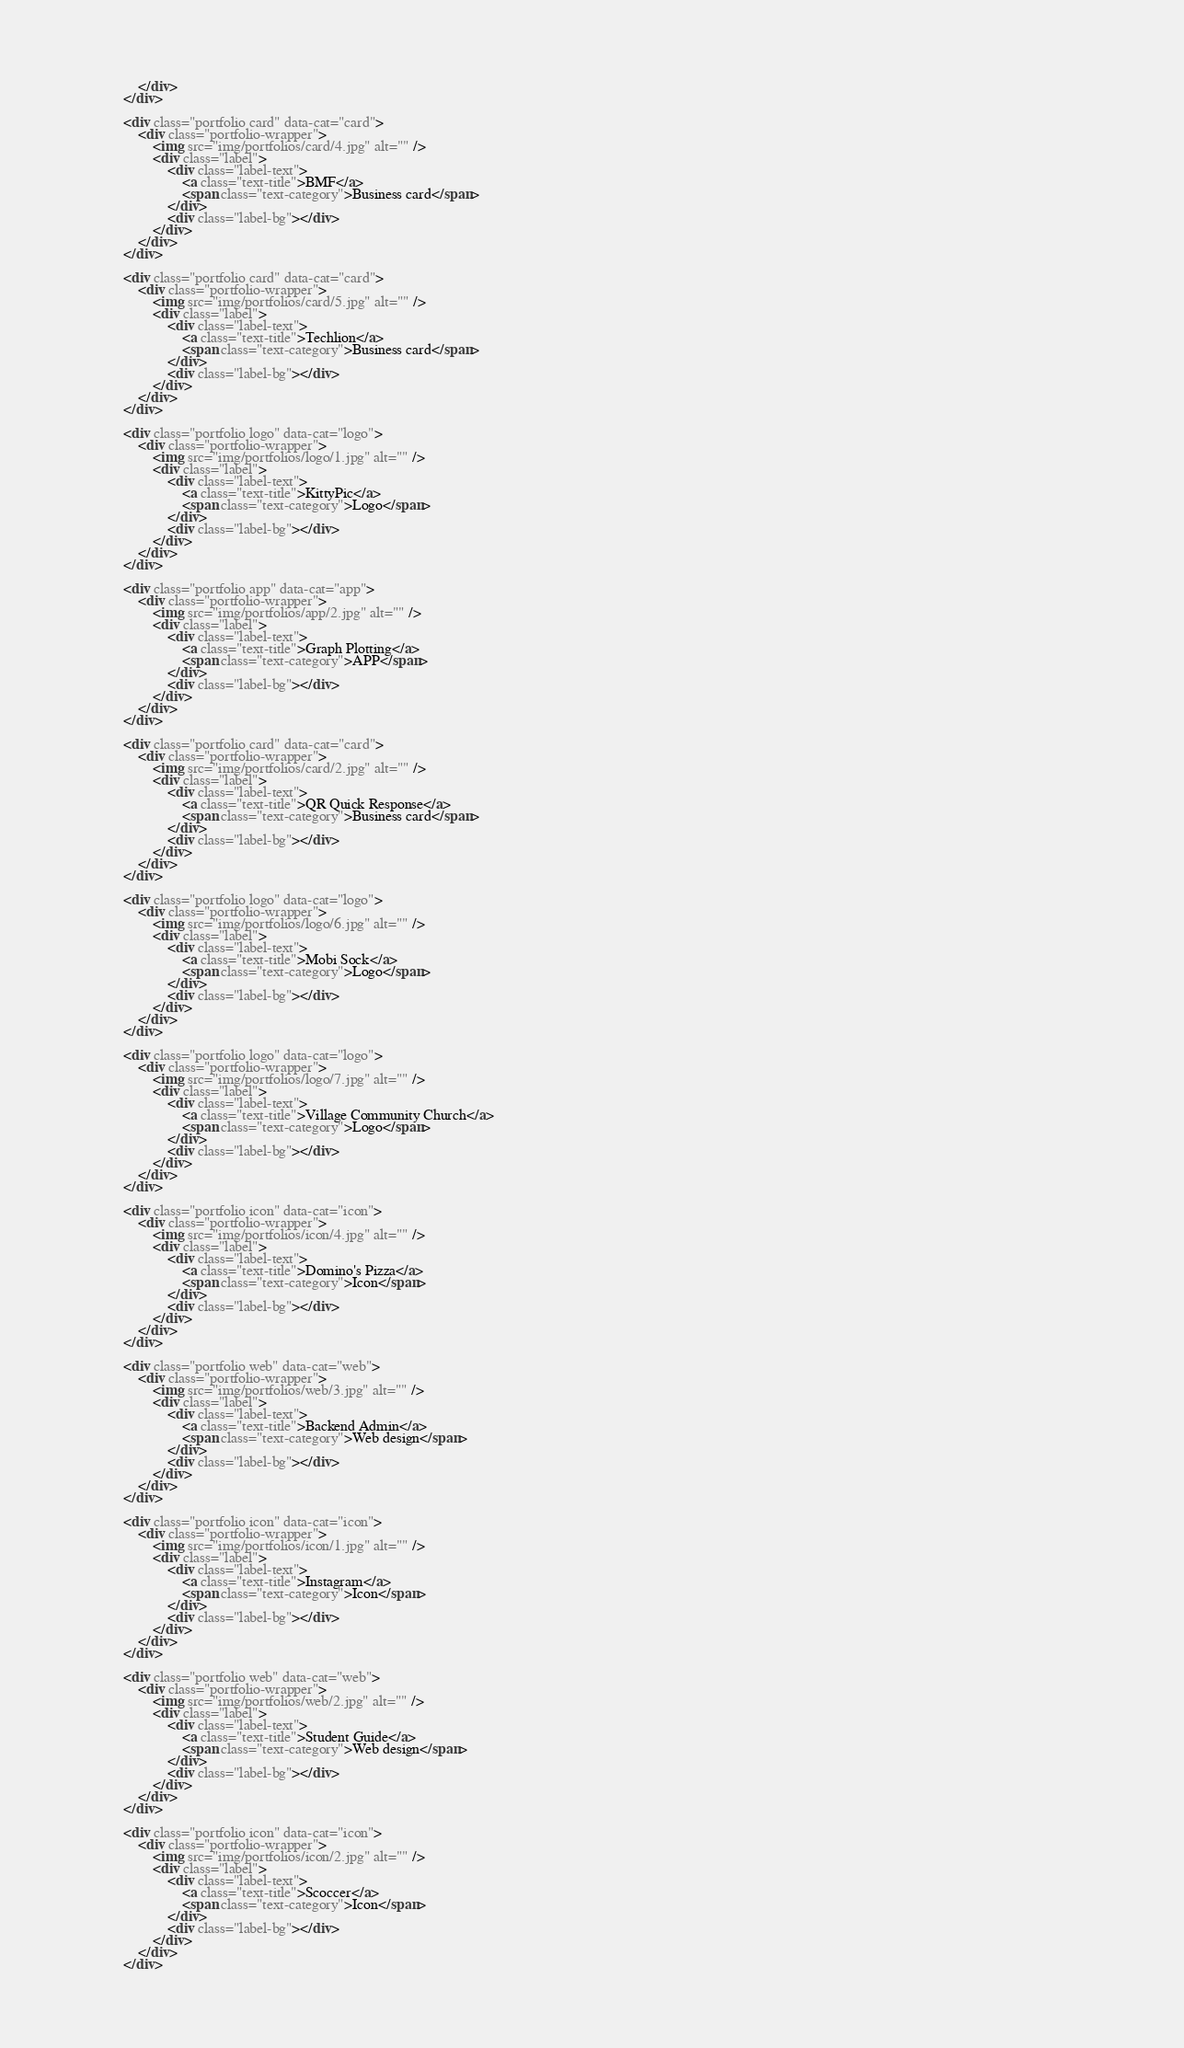Convert code to text. <code><loc_0><loc_0><loc_500><loc_500><_HTML_>				</div>
			</div>			
			
			<div class="portfolio card" data-cat="card">
				<div class="portfolio-wrapper">			
					<img src="img/portfolios/card/4.jpg" alt="" />
					<div class="label">
						<div class="label-text">
							<a class="text-title">BMF</a>
							<span class="text-category">Business card</span>
						</div>
						<div class="label-bg"></div>
					</div>
				</div>
			</div>	
			
			<div class="portfolio card" data-cat="card">
				<div class="portfolio-wrapper">			
					<img src="img/portfolios/card/5.jpg" alt="" />
					<div class="label">
						<div class="label-text">
							<a class="text-title">Techlion</a>
							<span class="text-category">Business card</span>
						</div>
						<div class="label-bg"></div>
					</div>
				</div>
			</div>	
			
			<div class="portfolio logo" data-cat="logo">
				<div class="portfolio-wrapper">			
					<img src="img/portfolios/logo/1.jpg" alt="" />
					<div class="label">
						<div class="label-text">
							<a class="text-title">KittyPic</a>
							<span class="text-category">Logo</span>
						</div>
						<div class="label-bg"></div>
					</div>
				</div>
			</div>																																							
			
			<div class="portfolio app" data-cat="app">
				<div class="portfolio-wrapper">			
					<img src="img/portfolios/app/2.jpg" alt="" />
					<div class="label">
						<div class="label-text">
							<a class="text-title">Graph Plotting</a>
							<span class="text-category">APP</span>
						</div>
						<div class="label-bg"></div>
					</div>
				</div>
			</div>														
			
			<div class="portfolio card" data-cat="card">
				<div class="portfolio-wrapper">			
					<img src="img/portfolios/card/2.jpg" alt="" />
					<div class="label">
						<div class="label-text">
							<a class="text-title">QR Quick Response</a>
							<span class="text-category">Business card</span>
						</div>
						<div class="label-bg"></div>
					</div>
				</div>
			</div>				

			<div class="portfolio logo" data-cat="logo">
				<div class="portfolio-wrapper">			
					<img src="img/portfolios/logo/6.jpg" alt="" />
					<div class="label">
						<div class="label-text">
							<a class="text-title">Mobi Sock</a>
							<span class="text-category">Logo</span>
						</div>
						<div class="label-bg"></div>
					</div>
				</div>
			</div>																	

			<div class="portfolio logo" data-cat="logo">
				<div class="portfolio-wrapper">			
					<img src="img/portfolios/logo/7.jpg" alt="" />
					<div class="label">
						<div class="label-text">
							<a class="text-title">Village Community Church</a>
							<span class="text-category">Logo</span>
						</div>
						<div class="label-bg"></div>
					</div>
				</div>
			</div>													
			
			<div class="portfolio icon" data-cat="icon">
				<div class="portfolio-wrapper">			
					<img src="img/portfolios/icon/4.jpg" alt="" />
					<div class="label">
						<div class="label-text">
							<a class="text-title">Domino's Pizza</a>
							<span class="text-category">Icon</span>
						</div>
						<div class="label-bg"></div>
					</div>
				</div>
			</div>							

			<div class="portfolio web" data-cat="web">
				<div class="portfolio-wrapper">						
					<img src="img/portfolios/web/3.jpg" alt="" />
					<div class="label">
						<div class="label-text">
							<a class="text-title">Backend Admin</a>
							<span class="text-category">Web design</span>
						</div>
						<div class="label-bg"></div>
					</div>
				</div>
			</div>																								

			<div class="portfolio icon" data-cat="icon">
				<div class="portfolio-wrapper">			
					<img src="img/portfolios/icon/1.jpg" alt="" />
					<div class="label">
						<div class="label-text">
							<a class="text-title">Instagram</a>
							<span class="text-category">Icon</span>
						</div>
						<div class="label-bg"></div>
					</div>
				</div>
			</div>				
			
			<div class="portfolio web" data-cat="web">
				<div class="portfolio-wrapper">						
					<img src="img/portfolios/web/2.jpg" alt="" />
					<div class="label">
						<div class="label-text">
							<a class="text-title">Student Guide</a>
							<span class="text-category">Web design</span>
						</div>
						<div class="label-bg"></div>
					</div>
				</div>
			</div>																	

			<div class="portfolio icon" data-cat="icon">
				<div class="portfolio-wrapper">
					<img src="img/portfolios/icon/2.jpg" alt="" />
					<div class="label">
						<div class="label-text">
							<a class="text-title">Scoccer</a>
							<span class="text-category">Icon</span>
						</div>
						<div class="label-bg"></div>
					</div>
				</div>
			</div>																																																																
</code> 